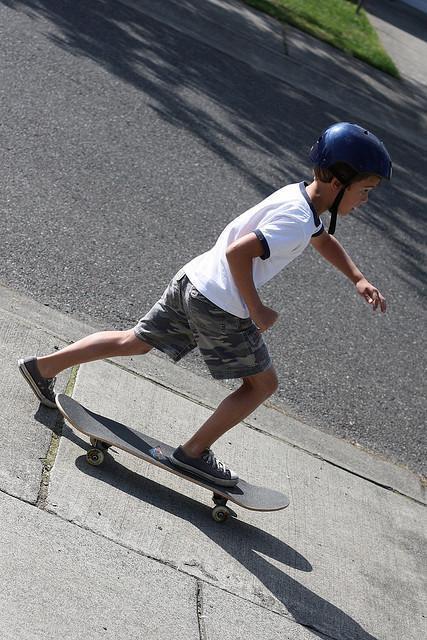How many elephants are pictured?
Give a very brief answer. 0. 